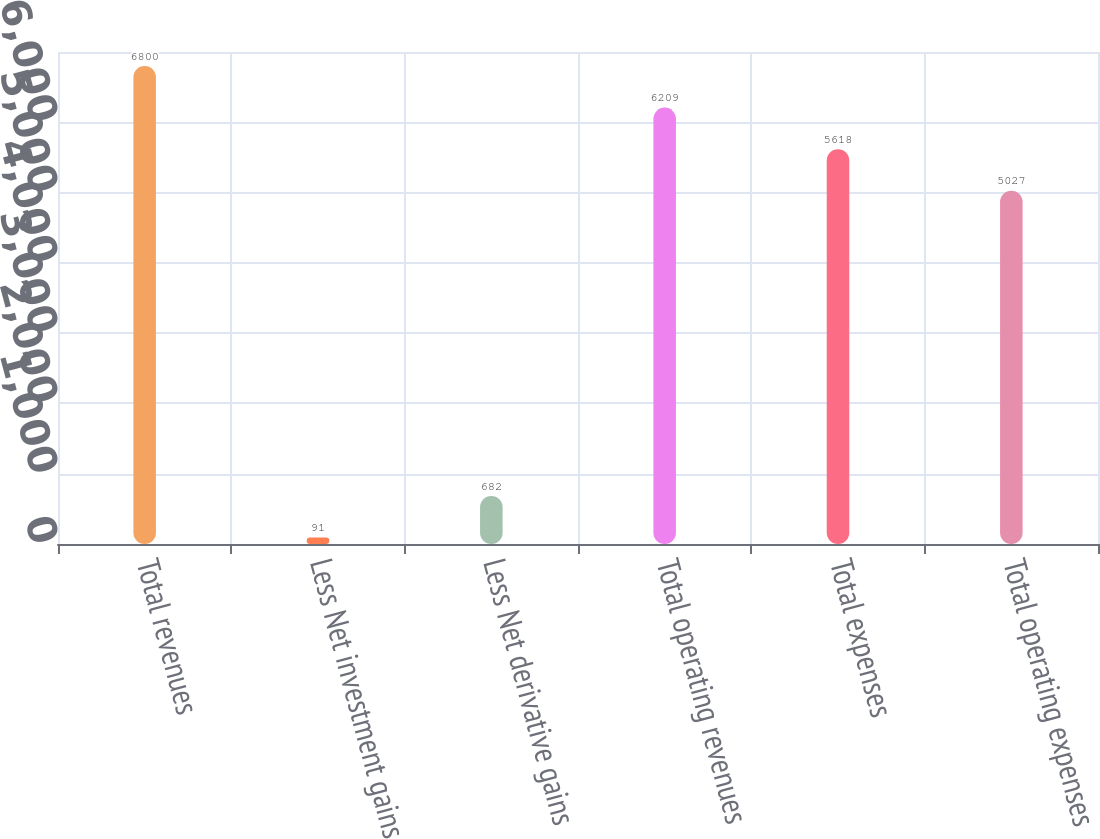Convert chart to OTSL. <chart><loc_0><loc_0><loc_500><loc_500><bar_chart><fcel>Total revenues<fcel>Less Net investment gains<fcel>Less Net derivative gains<fcel>Total operating revenues<fcel>Total expenses<fcel>Total operating expenses<nl><fcel>6800<fcel>91<fcel>682<fcel>6209<fcel>5618<fcel>5027<nl></chart> 